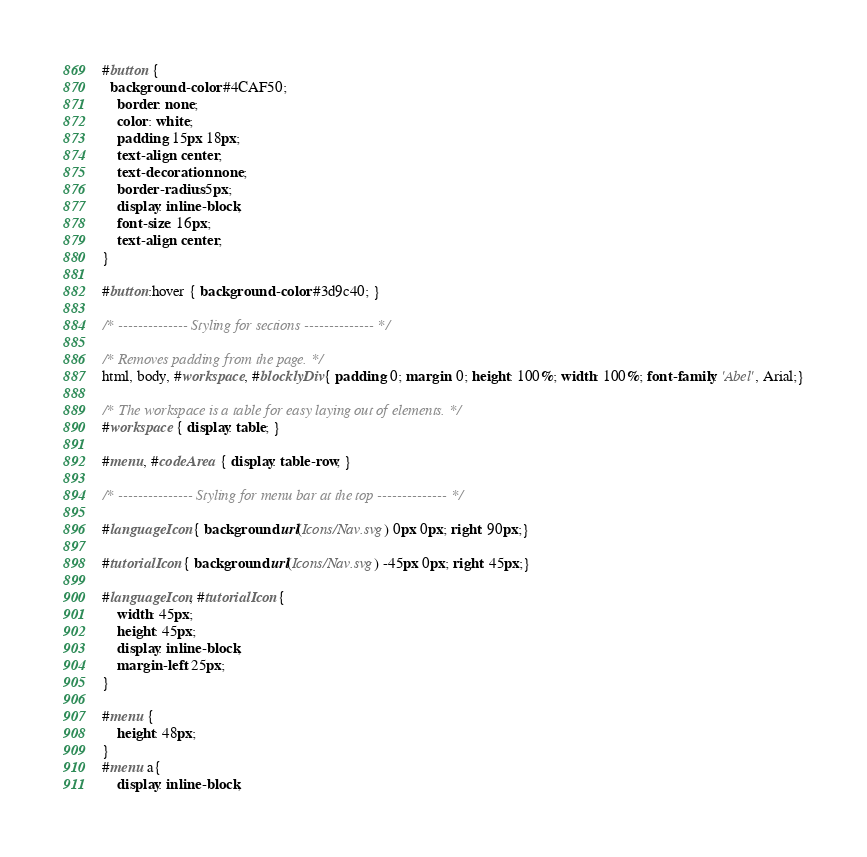Convert code to text. <code><loc_0><loc_0><loc_500><loc_500><_CSS_>#button {
  background-color: #4CAF50;
	border: none;
	color: white;
	padding: 15px 18px;
	text-align: center;
	text-decoration: none;
	border-radius: 5px;
	display: inline-block;
	font-size: 16px;
	text-align: center;
}

#button:hover { background-color: #3d9c40; }

/* -------------- Styling for sections -------------- */

/* Removes padding from the page. */
html, body, #workspace, #blocklyDiv{ padding: 0; margin: 0; height: 100%; width: 100%; font-family: 'Abel', Arial;}

/* The workspace is a table for easy laying out of elements. */
#workspace { display: table; }

#menu, #codeArea { display: table-row; }

/* --------------- Styling for menu bar at the top -------------- */

#languageIcon { background: url(Icons/Nav.svg) 0px 0px; right: 90px;}

#tutorialIcon { background: url(Icons/Nav.svg) -45px 0px; right: 45px;}

#languageIcon, #tutorialIcon {
	width: 45px;
	height: 45px;
	display: inline-block;
	margin-left: 25px;
}

#menu {
	height: 48px;
}
#menu a{
	display: inline-block;</code> 